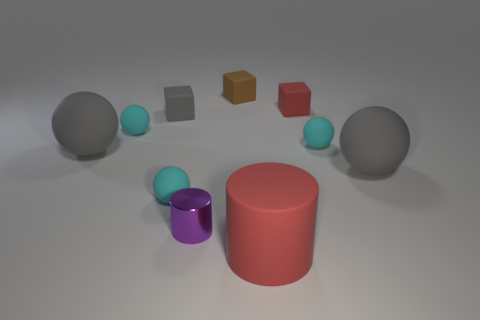Subtract all blue cylinders. How many cyan balls are left? 3 Subtract all brown balls. Subtract all purple cylinders. How many balls are left? 5 Subtract all cylinders. How many objects are left? 8 Subtract all brown blocks. Subtract all matte cylinders. How many objects are left? 8 Add 4 small brown blocks. How many small brown blocks are left? 5 Add 9 yellow matte cylinders. How many yellow matte cylinders exist? 9 Subtract 1 red cubes. How many objects are left? 9 